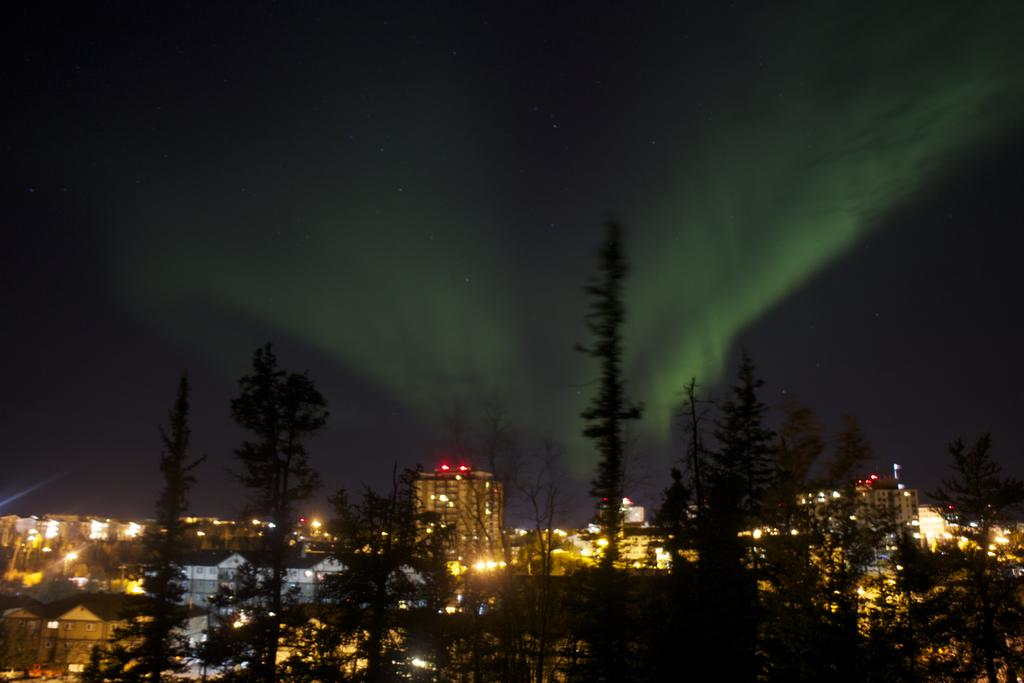What type of structures are present in the image? There is a group of buildings in the image. What can be seen illuminated in the image? There are lights visible in the image. What type of vegetation is present in the image? There is a group of trees in the image. What is visible in the background of the image? The sky is visible in the image. What type of dinner is being served in the image? There is no dinner present in the image; it features a group of buildings, lights, trees, and the sky. Can you hear the voice of the train conductor in the image? There is no train or train conductor present in the image. 